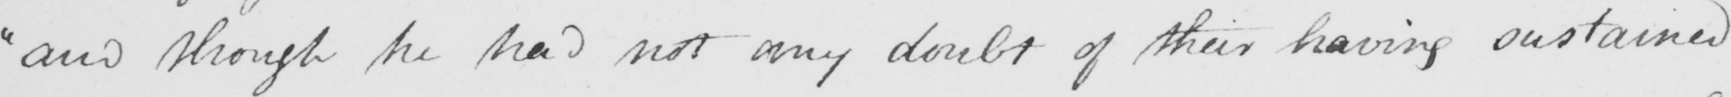Transcribe the text shown in this historical manuscript line. " and though he had not any doubt of their having sustained 